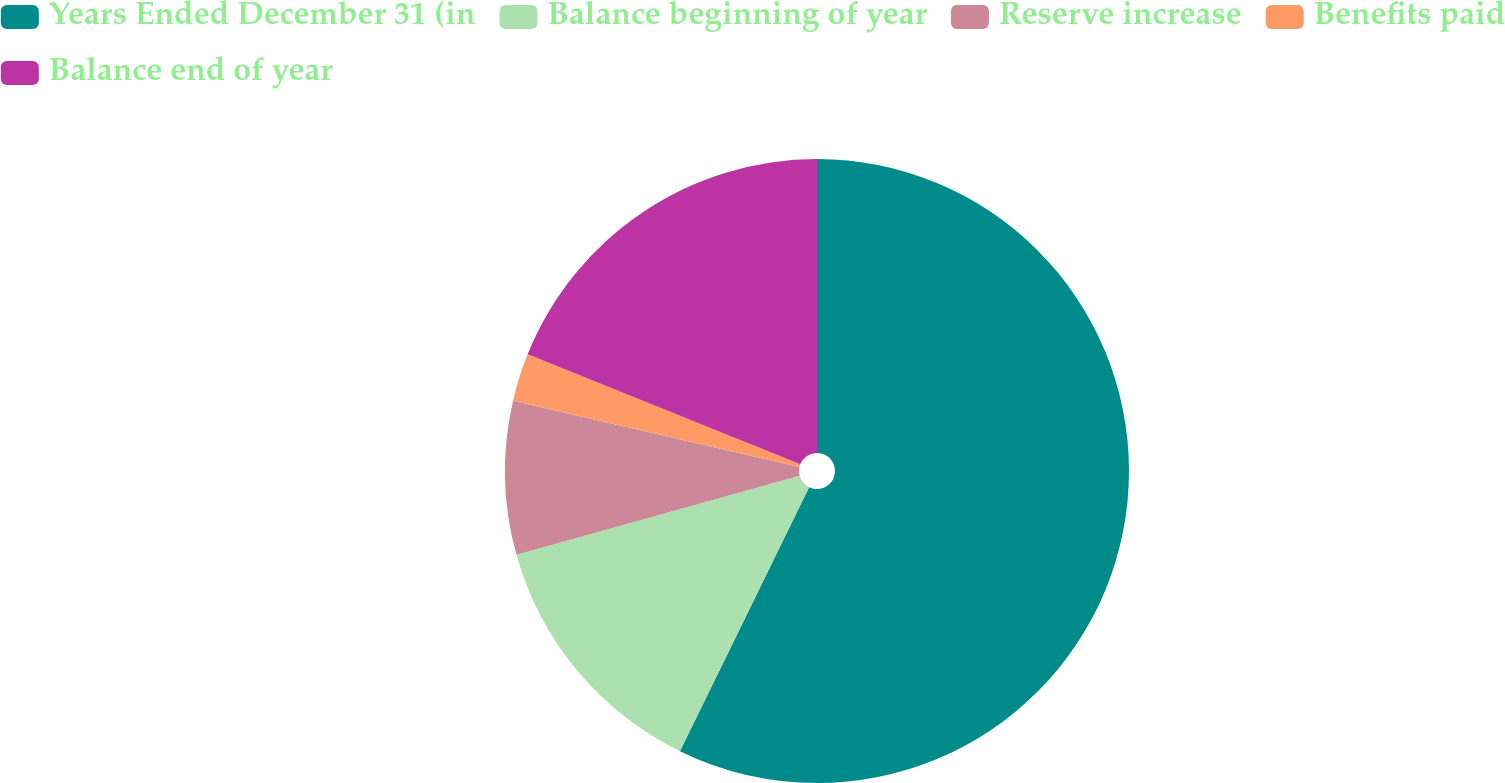<chart> <loc_0><loc_0><loc_500><loc_500><pie_chart><fcel>Years Ended December 31 (in<fcel>Balance beginning of year<fcel>Reserve increase<fcel>Benefits paid<fcel>Balance end of year<nl><fcel>57.24%<fcel>13.43%<fcel>7.95%<fcel>2.48%<fcel>18.9%<nl></chart> 